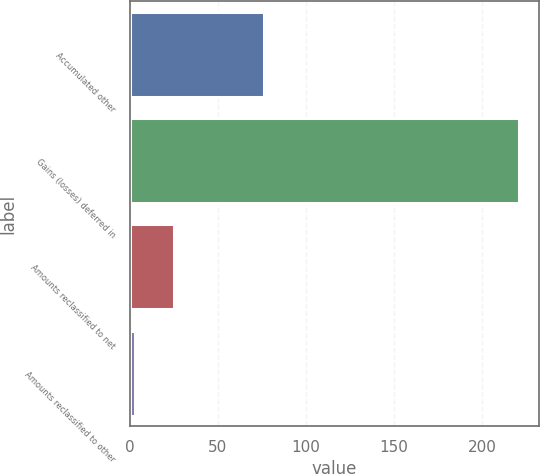Convert chart. <chart><loc_0><loc_0><loc_500><loc_500><bar_chart><fcel>Accumulated other<fcel>Gains (losses) deferred in<fcel>Amounts reclassified to net<fcel>Amounts reclassified to other<nl><fcel>76<fcel>221<fcel>24.8<fcel>3<nl></chart> 